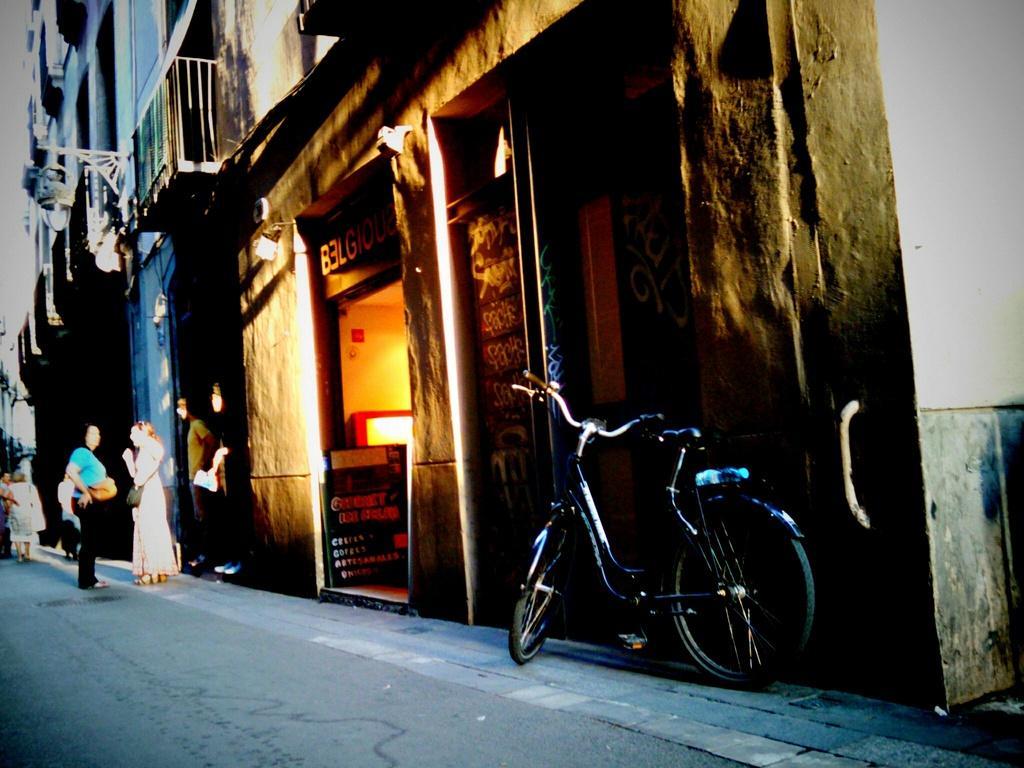Please provide a concise description of this image. This is an outside view. At the bottom of this image I can see the road. On the left side, I can see few people are standing in front of the building. On the right side, I can see a bicycle on the road. 